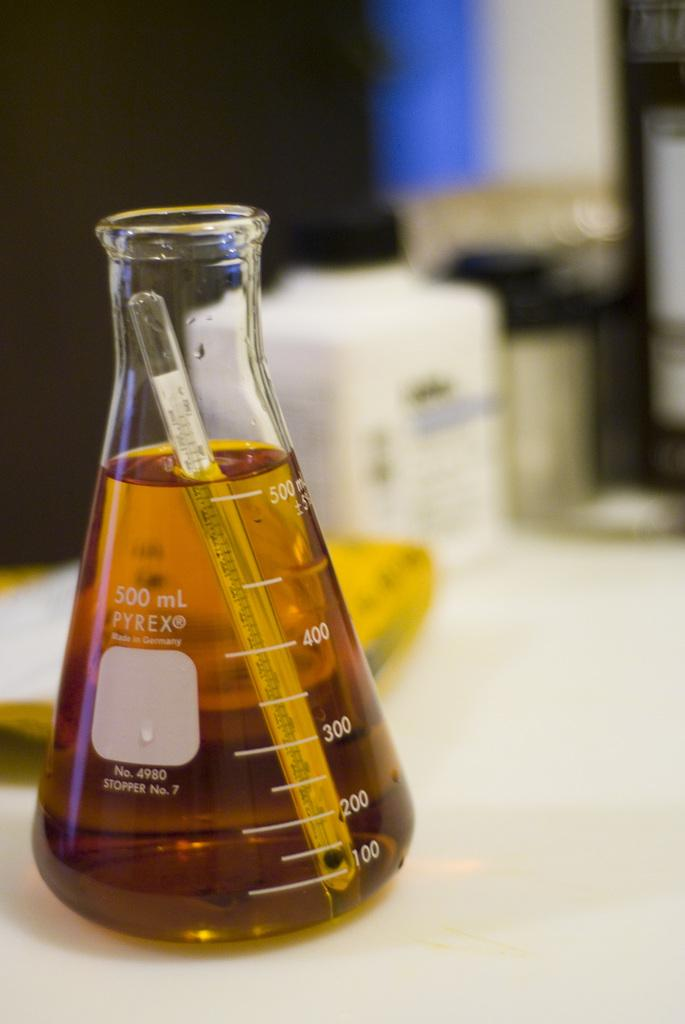<image>
Offer a succinct explanation of the picture presented. a flask that says 500 ml on it 